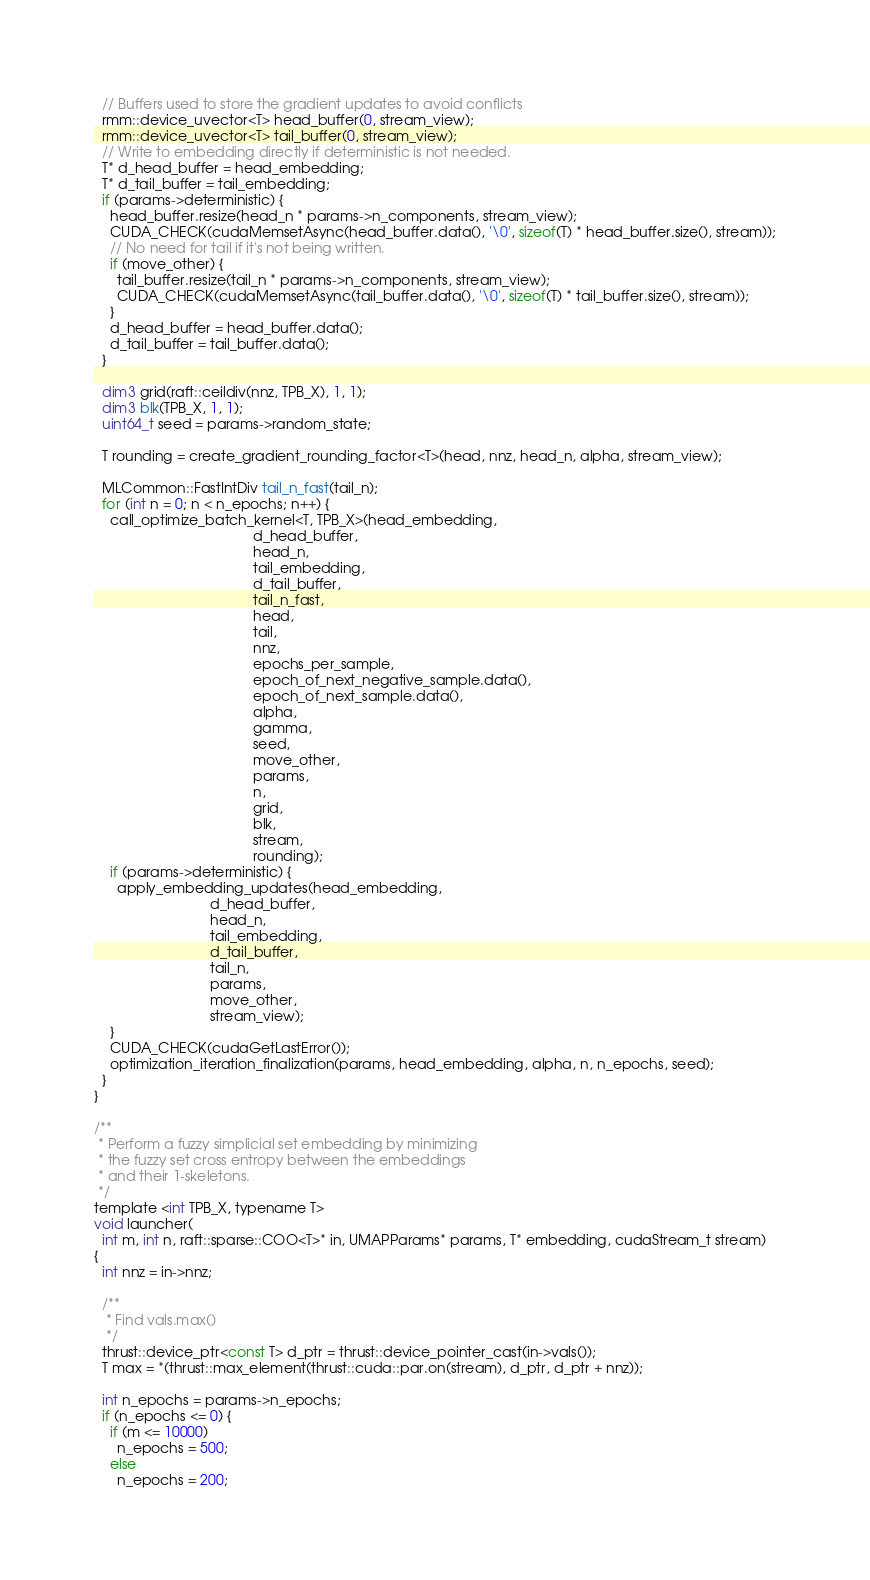<code> <loc_0><loc_0><loc_500><loc_500><_Cuda_>  // Buffers used to store the gradient updates to avoid conflicts
  rmm::device_uvector<T> head_buffer(0, stream_view);
  rmm::device_uvector<T> tail_buffer(0, stream_view);
  // Write to embedding directly if deterministic is not needed.
  T* d_head_buffer = head_embedding;
  T* d_tail_buffer = tail_embedding;
  if (params->deterministic) {
    head_buffer.resize(head_n * params->n_components, stream_view);
    CUDA_CHECK(cudaMemsetAsync(head_buffer.data(), '\0', sizeof(T) * head_buffer.size(), stream));
    // No need for tail if it's not being written.
    if (move_other) {
      tail_buffer.resize(tail_n * params->n_components, stream_view);
      CUDA_CHECK(cudaMemsetAsync(tail_buffer.data(), '\0', sizeof(T) * tail_buffer.size(), stream));
    }
    d_head_buffer = head_buffer.data();
    d_tail_buffer = tail_buffer.data();
  }

  dim3 grid(raft::ceildiv(nnz, TPB_X), 1, 1);
  dim3 blk(TPB_X, 1, 1);
  uint64_t seed = params->random_state;

  T rounding = create_gradient_rounding_factor<T>(head, nnz, head_n, alpha, stream_view);

  MLCommon::FastIntDiv tail_n_fast(tail_n);
  for (int n = 0; n < n_epochs; n++) {
    call_optimize_batch_kernel<T, TPB_X>(head_embedding,
                                         d_head_buffer,
                                         head_n,
                                         tail_embedding,
                                         d_tail_buffer,
                                         tail_n_fast,
                                         head,
                                         tail,
                                         nnz,
                                         epochs_per_sample,
                                         epoch_of_next_negative_sample.data(),
                                         epoch_of_next_sample.data(),
                                         alpha,
                                         gamma,
                                         seed,
                                         move_other,
                                         params,
                                         n,
                                         grid,
                                         blk,
                                         stream,
                                         rounding);
    if (params->deterministic) {
      apply_embedding_updates(head_embedding,
                              d_head_buffer,
                              head_n,
                              tail_embedding,
                              d_tail_buffer,
                              tail_n,
                              params,
                              move_other,
                              stream_view);
    }
    CUDA_CHECK(cudaGetLastError());
    optimization_iteration_finalization(params, head_embedding, alpha, n, n_epochs, seed);
  }
}

/**
 * Perform a fuzzy simplicial set embedding by minimizing
 * the fuzzy set cross entropy between the embeddings
 * and their 1-skeletons.
 */
template <int TPB_X, typename T>
void launcher(
  int m, int n, raft::sparse::COO<T>* in, UMAPParams* params, T* embedding, cudaStream_t stream)
{
  int nnz = in->nnz;

  /**
   * Find vals.max()
   */
  thrust::device_ptr<const T> d_ptr = thrust::device_pointer_cast(in->vals());
  T max = *(thrust::max_element(thrust::cuda::par.on(stream), d_ptr, d_ptr + nnz));

  int n_epochs = params->n_epochs;
  if (n_epochs <= 0) {
    if (m <= 10000)
      n_epochs = 500;
    else
      n_epochs = 200;</code> 